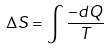<formula> <loc_0><loc_0><loc_500><loc_500>\Delta S = \int \frac { - d Q } { T }</formula> 